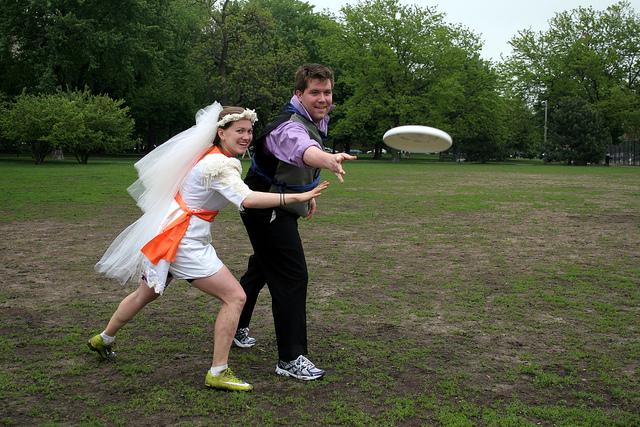How many articles of clothing is the woman holding the white frisby earring?
Concise answer only. 4. What does the woman have on her head?
Write a very short answer. Veil. What color is the girl with the frisbee's shirt?
Be succinct. White. Is she wearing a wedding dress?
Short answer required. Yes. Is the man about to catch the frisbee?
Short answer required. Yes. How many humans are there?
Write a very short answer. 2. Is the girl dancing?
Answer briefly. No. What are they trying to fly?
Keep it brief. Frisbee. How many people are in the photo?
Short answer required. 2. What is the name of the sport these people are playing?
Concise answer only. Frisbee. 